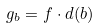<formula> <loc_0><loc_0><loc_500><loc_500>g _ { b } = f \cdot d ( b )</formula> 